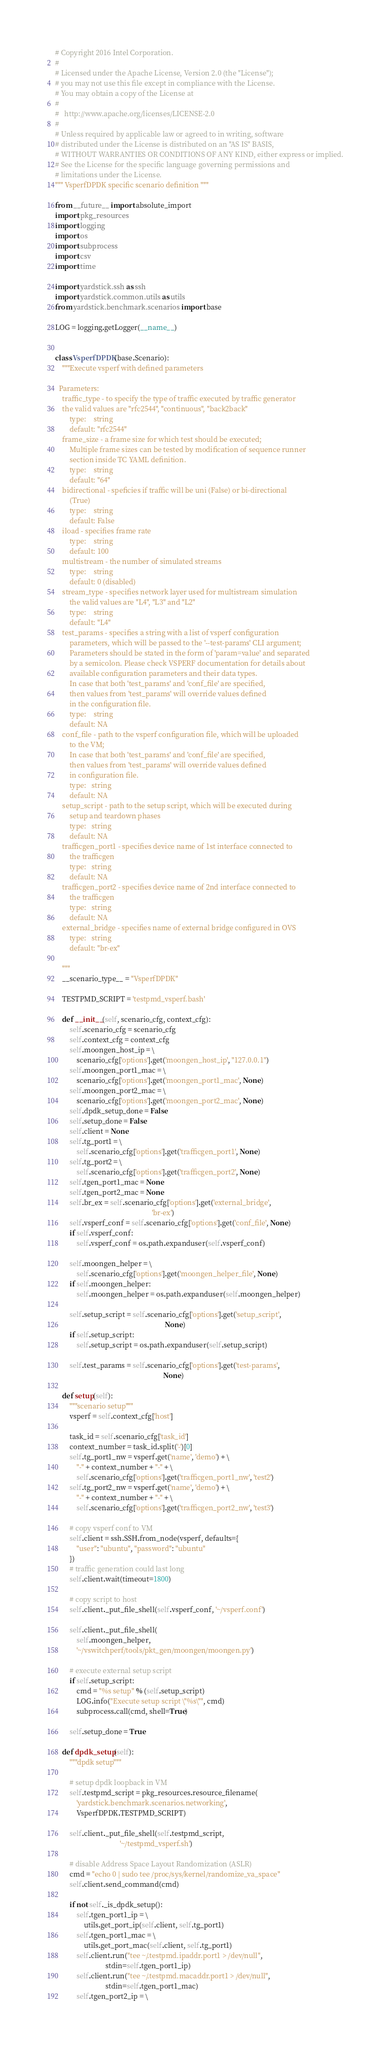<code> <loc_0><loc_0><loc_500><loc_500><_Python_># Copyright 2016 Intel Corporation.
#
# Licensed under the Apache License, Version 2.0 (the "License");
# you may not use this file except in compliance with the License.
# You may obtain a copy of the License at
#
#   http://www.apache.org/licenses/LICENSE-2.0
#
# Unless required by applicable law or agreed to in writing, software
# distributed under the License is distributed on an "AS IS" BASIS,
# WITHOUT WARRANTIES OR CONDITIONS OF ANY KIND, either express or implied.
# See the License for the specific language governing permissions and
# limitations under the License.
""" VsperfDPDK specific scenario definition """

from __future__ import absolute_import
import pkg_resources
import logging
import os
import subprocess
import csv
import time

import yardstick.ssh as ssh
import yardstick.common.utils as utils
from yardstick.benchmark.scenarios import base

LOG = logging.getLogger(__name__)


class VsperfDPDK(base.Scenario):
    """Execute vsperf with defined parameters

  Parameters:
    traffic_type - to specify the type of traffic executed by traffic generator
    the valid values are "rfc2544", "continuous", "back2back"
        type:    string
        default: "rfc2544"
    frame_size - a frame size for which test should be executed;
        Multiple frame sizes can be tested by modification of sequence runner
        section inside TC YAML definition.
        type:    string
        default: "64"
    bidirectional - speficies if traffic will be uni (False) or bi-directional
        (True)
        type:    string
        default: False
    iload - specifies frame rate
        type:    string
        default: 100
    multistream - the number of simulated streams
        type:    string
        default: 0 (disabled)
    stream_type - specifies network layer used for multistream simulation
        the valid values are "L4", "L3" and "L2"
        type:    string
        default: "L4"
    test_params - specifies a string with a list of vsperf configuration
        parameters, which will be passed to the '--test-params' CLI argument;
        Parameters should be stated in the form of 'param=value' and separated
        by a semicolon. Please check VSPERF documentation for details about
        available configuration parameters and their data types.
        In case that both 'test_params' and 'conf_file' are specified,
        then values from 'test_params' will override values defined
        in the configuration file.
        type:    string
        default: NA
    conf_file - path to the vsperf configuration file, which will be uploaded
        to the VM;
        In case that both 'test_params' and 'conf_file' are specified,
        then values from 'test_params' will override values defined
        in configuration file.
        type:   string
        default: NA
    setup_script - path to the setup script, which will be executed during
        setup and teardown phases
        type:   string
        default: NA
    trafficgen_port1 - specifies device name of 1st interface connected to
        the trafficgen
        type:   string
        default: NA
    trafficgen_port2 - specifies device name of 2nd interface connected to
        the trafficgen
        type:   string
        default: NA
    external_bridge - specifies name of external bridge configured in OVS
        type:   string
        default: "br-ex"

    """
    __scenario_type__ = "VsperfDPDK"

    TESTPMD_SCRIPT = 'testpmd_vsperf.bash'

    def __init__(self, scenario_cfg, context_cfg):
        self.scenario_cfg = scenario_cfg
        self.context_cfg = context_cfg
        self.moongen_host_ip = \
            scenario_cfg['options'].get('moongen_host_ip', "127.0.0.1")
        self.moongen_port1_mac = \
            scenario_cfg['options'].get('moongen_port1_mac', None)
        self.moongen_port2_mac = \
            scenario_cfg['options'].get('moongen_port2_mac', None)
        self.dpdk_setup_done = False
        self.setup_done = False
        self.client = None
        self.tg_port1 = \
            self.scenario_cfg['options'].get('trafficgen_port1', None)
        self.tg_port2 = \
            self.scenario_cfg['options'].get('trafficgen_port2', None)
        self.tgen_port1_mac = None
        self.tgen_port2_mac = None
        self.br_ex = self.scenario_cfg['options'].get('external_bridge',
                                                      'br-ex')
        self.vsperf_conf = self.scenario_cfg['options'].get('conf_file', None)
        if self.vsperf_conf:
            self.vsperf_conf = os.path.expanduser(self.vsperf_conf)

        self.moongen_helper = \
            self.scenario_cfg['options'].get('moongen_helper_file', None)
        if self.moongen_helper:
            self.moongen_helper = os.path.expanduser(self.moongen_helper)

        self.setup_script = self.scenario_cfg['options'].get('setup_script',
                                                             None)
        if self.setup_script:
            self.setup_script = os.path.expanduser(self.setup_script)

        self.test_params = self.scenario_cfg['options'].get('test-params',
                                                            None)

    def setup(self):
        """scenario setup"""
        vsperf = self.context_cfg['host']

        task_id = self.scenario_cfg['task_id']
        context_number = task_id.split('-')[0]
        self.tg_port1_nw = vsperf.get('name', 'demo') + \
            "-" + context_number + "-" + \
            self.scenario_cfg['options'].get('trafficgen_port1_nw', 'test2')
        self.tg_port2_nw = vsperf.get('name', 'demo') + \
            "-" + context_number + "-" + \
            self.scenario_cfg['options'].get('trafficgen_port2_nw', 'test3')

        # copy vsperf conf to VM
        self.client = ssh.SSH.from_node(vsperf, defaults={
            "user": "ubuntu", "password": "ubuntu"
        })
        # traffic generation could last long
        self.client.wait(timeout=1800)

        # copy script to host
        self.client._put_file_shell(self.vsperf_conf, '~/vsperf.conf')

        self.client._put_file_shell(
            self.moongen_helper,
            '~/vswitchperf/tools/pkt_gen/moongen/moongen.py')

        # execute external setup script
        if self.setup_script:
            cmd = "%s setup" % (self.setup_script)
            LOG.info("Execute setup script \"%s\"", cmd)
            subprocess.call(cmd, shell=True)

        self.setup_done = True

    def dpdk_setup(self):
        """dpdk setup"""

        # setup dpdk loopback in VM
        self.testpmd_script = pkg_resources.resource_filename(
            'yardstick.benchmark.scenarios.networking',
            VsperfDPDK.TESTPMD_SCRIPT)

        self.client._put_file_shell(self.testpmd_script,
                                    '~/testpmd_vsperf.sh')

        # disable Address Space Layout Randomization (ASLR)
        cmd = "echo 0 | sudo tee /proc/sys/kernel/randomize_va_space"
        self.client.send_command(cmd)

        if not self._is_dpdk_setup():
            self.tgen_port1_ip = \
                utils.get_port_ip(self.client, self.tg_port1)
            self.tgen_port1_mac = \
                utils.get_port_mac(self.client, self.tg_port1)
            self.client.run("tee ~/.testpmd.ipaddr.port1 > /dev/null",
                            stdin=self.tgen_port1_ip)
            self.client.run("tee ~/.testpmd.macaddr.port1 > /dev/null",
                            stdin=self.tgen_port1_mac)
            self.tgen_port2_ip = \</code> 